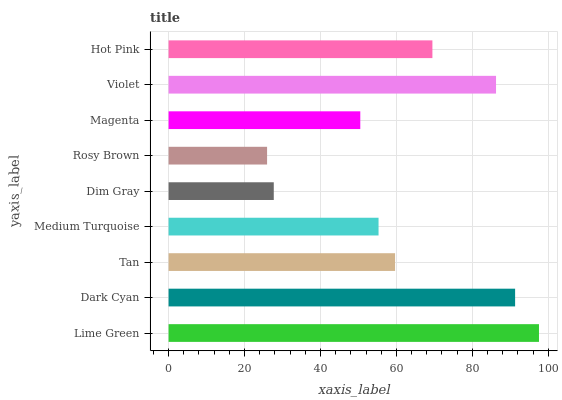Is Rosy Brown the minimum?
Answer yes or no. Yes. Is Lime Green the maximum?
Answer yes or no. Yes. Is Dark Cyan the minimum?
Answer yes or no. No. Is Dark Cyan the maximum?
Answer yes or no. No. Is Lime Green greater than Dark Cyan?
Answer yes or no. Yes. Is Dark Cyan less than Lime Green?
Answer yes or no. Yes. Is Dark Cyan greater than Lime Green?
Answer yes or no. No. Is Lime Green less than Dark Cyan?
Answer yes or no. No. Is Tan the high median?
Answer yes or no. Yes. Is Tan the low median?
Answer yes or no. Yes. Is Violet the high median?
Answer yes or no. No. Is Medium Turquoise the low median?
Answer yes or no. No. 